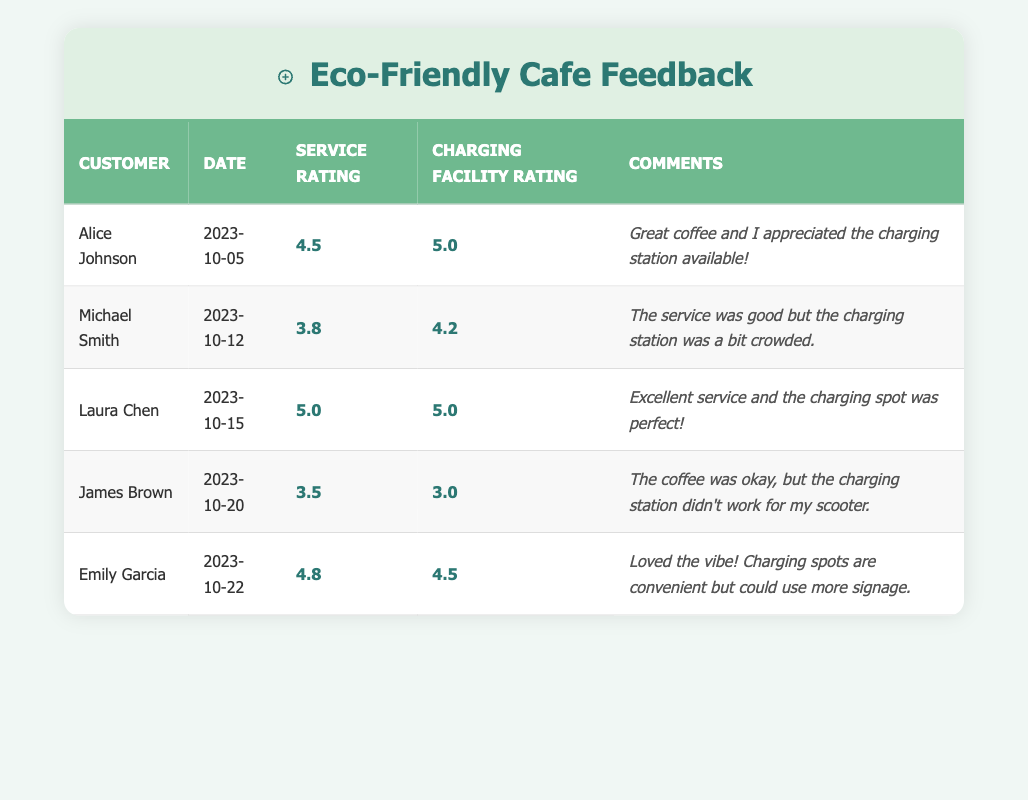What is the highest service rating given by a customer? Looking at the service ratings column, the highest rating is 5.0 given by Laura Chen.
Answer: 5.0 What was the date of Michael Smith's visit? The date of visit is listed in the table under Michael Smith's entry as 2023-10-12.
Answer: 2023-10-12 What is the average rating for charging facilities across all customers? To calculate the average: (5.0 + 4.2 + 5.0 + 3.0 + 4.5) = 21.7. There are 5 ratings, so the average is 21.7 / 5 = 4.34.
Answer: 4.34 Did any customer report issues with the charging station? Yes, James Brown mentioned that the charging station didn't work for his scooter.
Answer: Yes How many customers rated the charging facilities higher than 4.0? The ratings above 4.0 are from Alice Johnson (5.0), Michael Smith (4.2), Laura Chen (5.0), and Emily Garcia (4.5), making it 4 customers in total.
Answer: 4 customers What is the difference between the highest and lowest service rating? The highest service rating is 5.0 (Laura Chen) and the lowest is 3.5 (James Brown). Thus, the difference is 5.0 - 3.5 = 1.5.
Answer: 1.5 Which customer provided the comment about needing more signage for the charging spots? Emily Garcia commented about the need for more signage regarding the charging spots.
Answer: Emily Garcia What is the overall impression of the service based on customer comments? Most comments indicate a positive experience with only one negative remark from James Brown regarding the charging station. The general sentiment is favorable.
Answer: Overall positive 